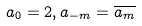<formula> <loc_0><loc_0><loc_500><loc_500>a _ { 0 } = 2 , a _ { - m } = \overline { a _ { m } }</formula> 